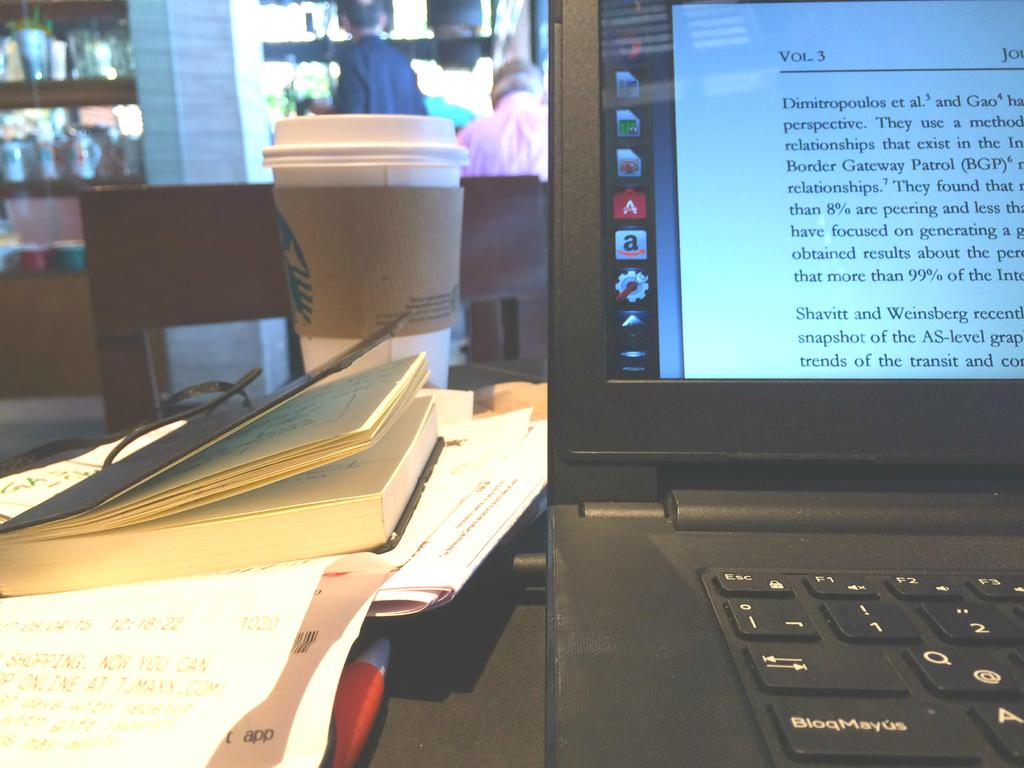<image>
Create a compact narrative representing the image presented. A picture of a Starbucks cup and a laptop with a book on it that starts with the word Dimitropolous. 